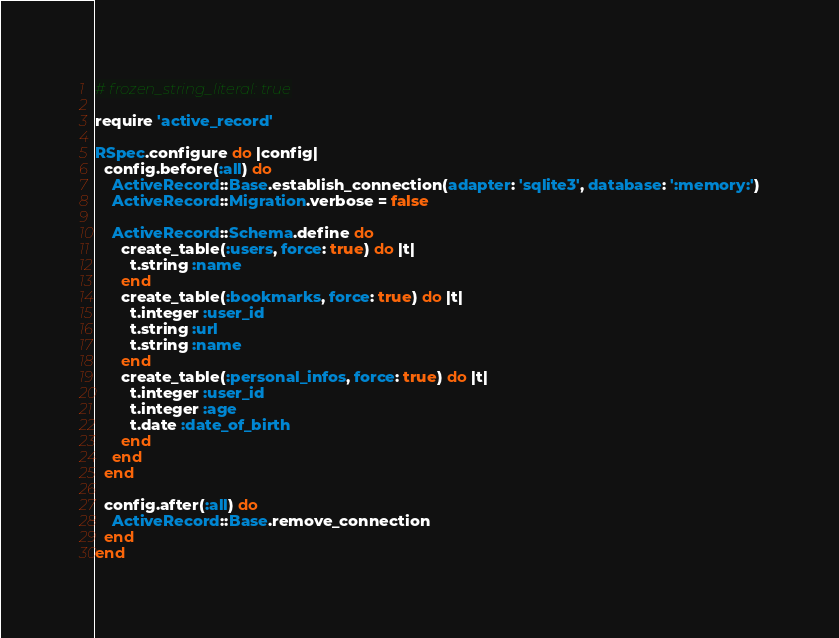<code> <loc_0><loc_0><loc_500><loc_500><_Ruby_># frozen_string_literal: true

require 'active_record'

RSpec.configure do |config|
  config.before(:all) do
    ActiveRecord::Base.establish_connection(adapter: 'sqlite3', database: ':memory:')
    ActiveRecord::Migration.verbose = false

    ActiveRecord::Schema.define do
      create_table(:users, force: true) do |t|
        t.string :name
      end
      create_table(:bookmarks, force: true) do |t|
        t.integer :user_id
        t.string :url
        t.string :name
      end
      create_table(:personal_infos, force: true) do |t|
        t.integer :user_id
        t.integer :age
        t.date :date_of_birth
      end
    end
  end

  config.after(:all) do
    ActiveRecord::Base.remove_connection
  end
end
</code> 